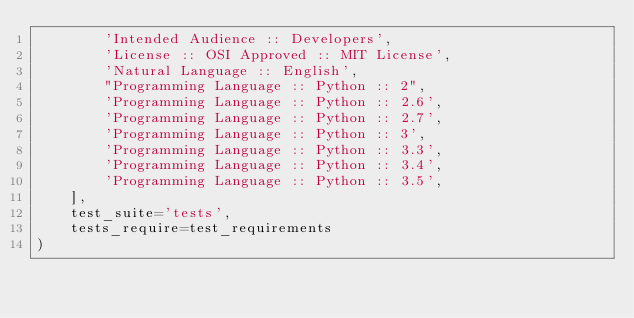<code> <loc_0><loc_0><loc_500><loc_500><_Python_>        'Intended Audience :: Developers',
        'License :: OSI Approved :: MIT License',
        'Natural Language :: English',
        "Programming Language :: Python :: 2",
        'Programming Language :: Python :: 2.6',
        'Programming Language :: Python :: 2.7',
        'Programming Language :: Python :: 3',
        'Programming Language :: Python :: 3.3',
        'Programming Language :: Python :: 3.4',
        'Programming Language :: Python :: 3.5',
    ],
    test_suite='tests',
    tests_require=test_requirements
)
</code> 